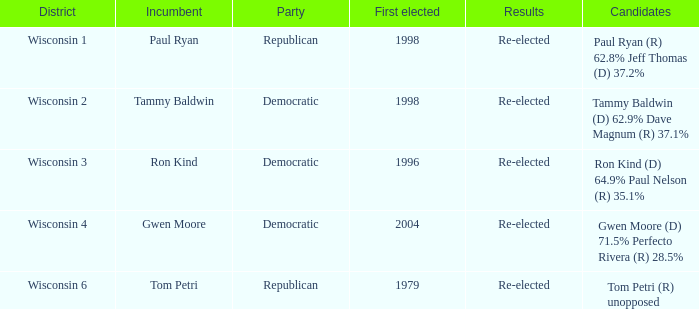In 1998, what area first voted for a democratic incumbent? Wisconsin 2. 